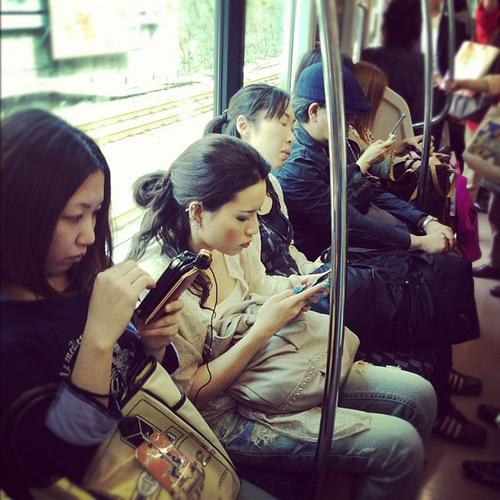Mention one accessory that a woman is carrying in her lap in the image. A black and beige purse. Describe the appearance of a man in the image. A man with a blue hat is seated on a train. What type of hat is a man wearing in the image, and what color is it? A man is wearing a blue cap. What type of pants does a woman wear in the image and what color are they? A woman is wearing light blue jeans. Explain what a particular woman in the image seems to be doing while seated. A woman is falling asleep on the train. What are the passengers on the train mostly looking at? Most people on the train are looking at their phones. In a few words, mention an activity a woman is doing on the train. A woman is looking at her cell phone. State the primary mode of transportation depicted in the image. People are riding a public bus or train. Briefly describe one woman's hairstyle in the image. One woman has her hair in a bun. Identify an object in the image that is commonly used for communication. A silver and black cellphone case. 